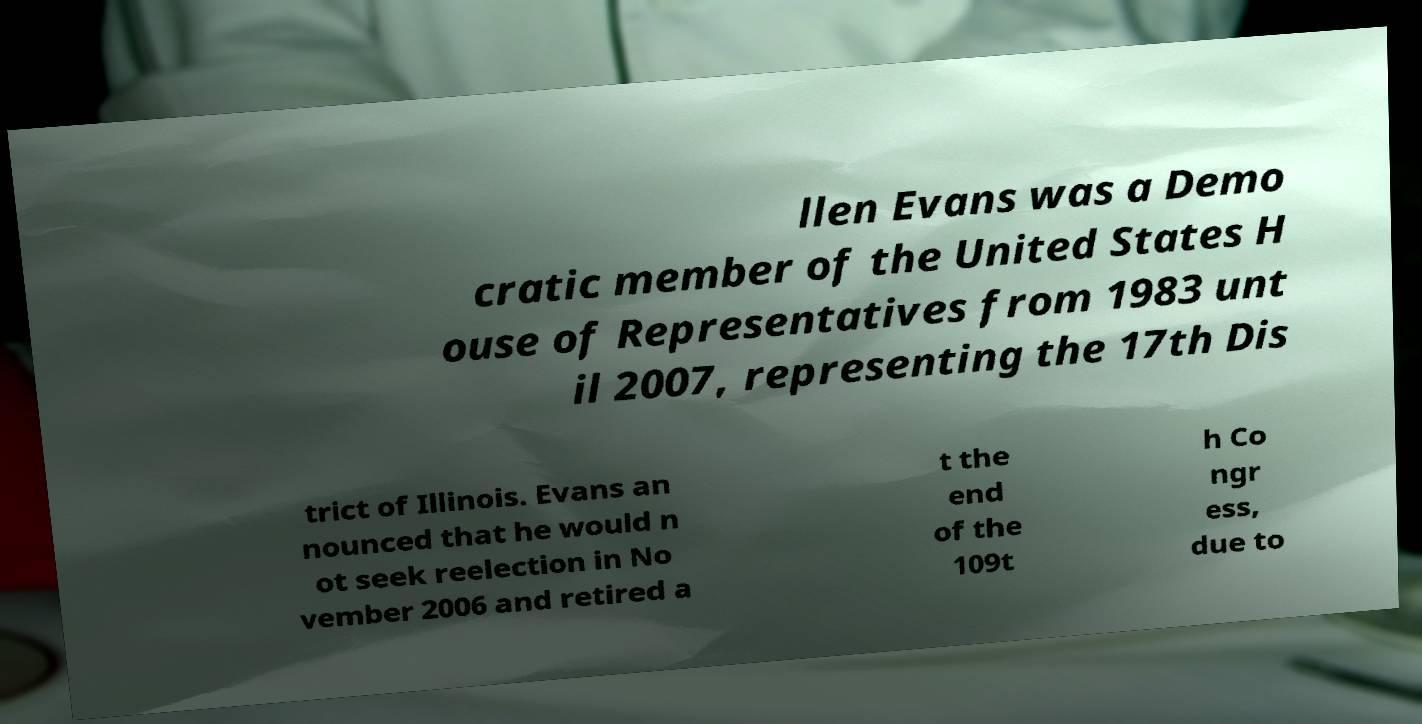What messages or text are displayed in this image? I need them in a readable, typed format. llen Evans was a Demo cratic member of the United States H ouse of Representatives from 1983 unt il 2007, representing the 17th Dis trict of Illinois. Evans an nounced that he would n ot seek reelection in No vember 2006 and retired a t the end of the 109t h Co ngr ess, due to 